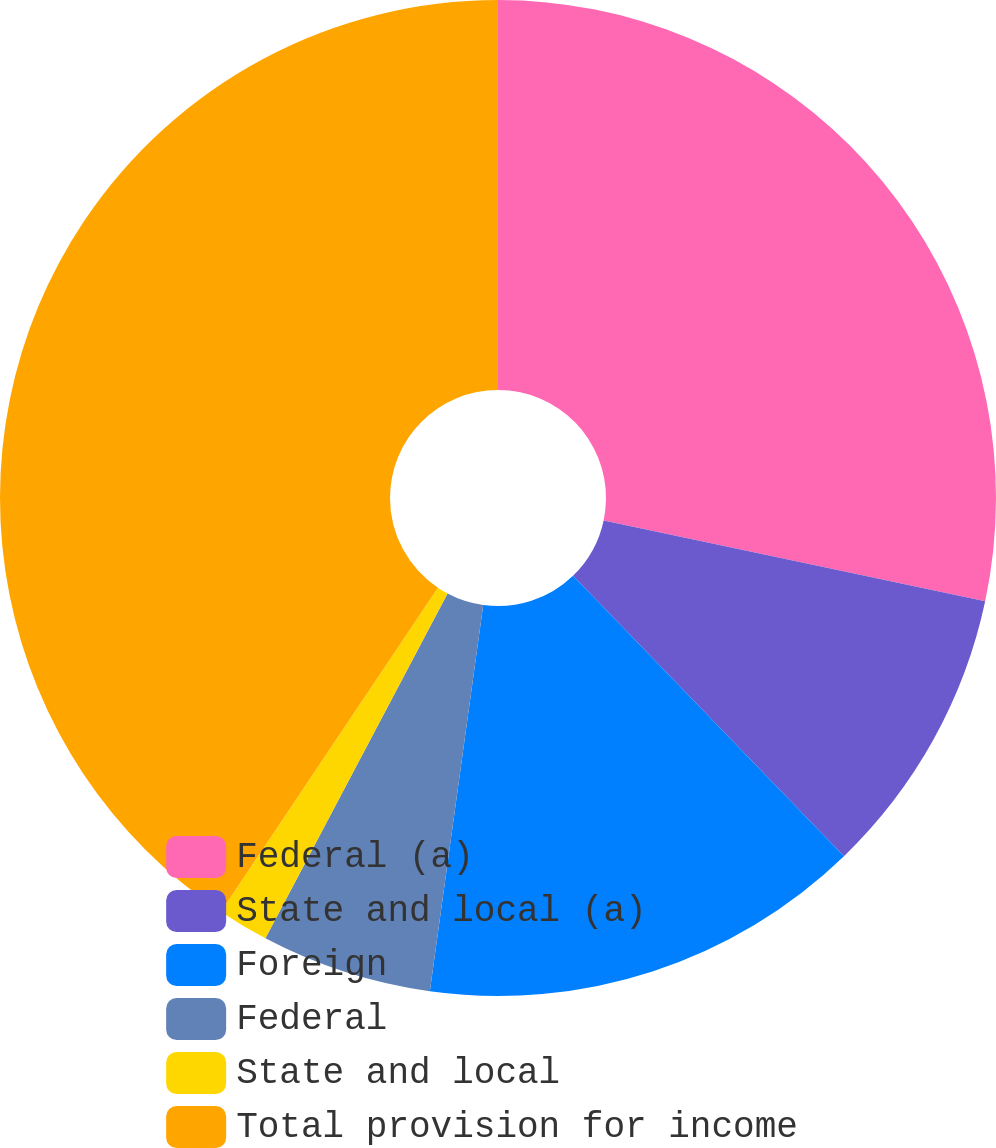<chart> <loc_0><loc_0><loc_500><loc_500><pie_chart><fcel>Federal (a)<fcel>State and local (a)<fcel>Foreign<fcel>Federal<fcel>State and local<fcel>Total provision for income<nl><fcel>28.33%<fcel>9.45%<fcel>14.41%<fcel>5.55%<fcel>1.66%<fcel>40.61%<nl></chart> 